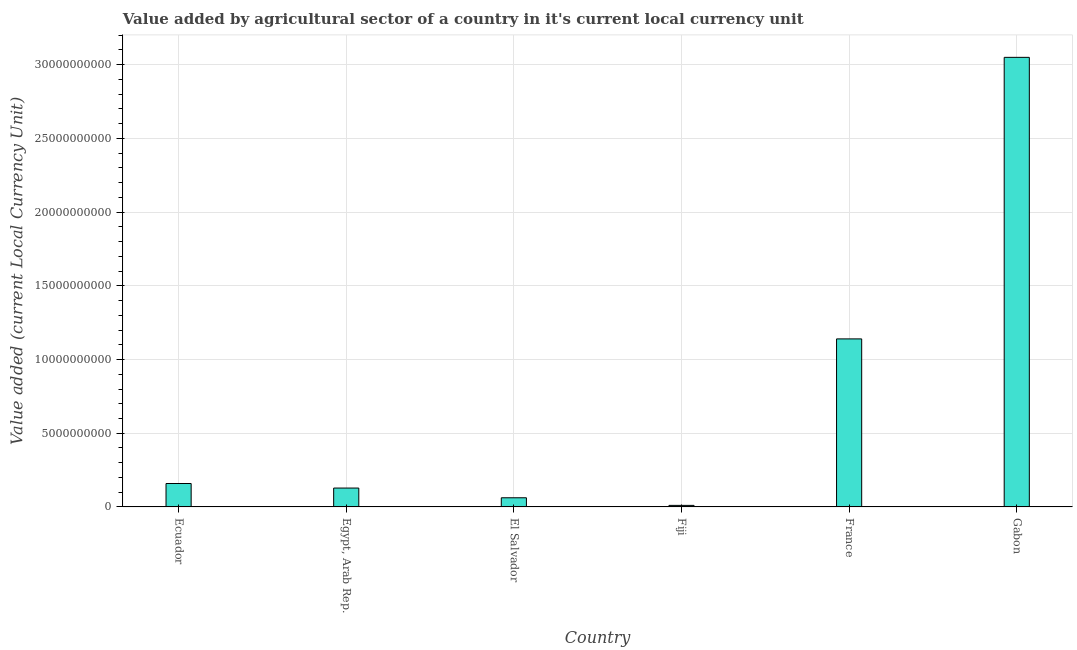Does the graph contain grids?
Give a very brief answer. Yes. What is the title of the graph?
Offer a very short reply. Value added by agricultural sector of a country in it's current local currency unit. What is the label or title of the X-axis?
Make the answer very short. Country. What is the label or title of the Y-axis?
Provide a succinct answer. Value added (current Local Currency Unit). What is the value added by agriculture sector in France?
Provide a short and direct response. 1.14e+1. Across all countries, what is the maximum value added by agriculture sector?
Your answer should be very brief. 3.05e+1. Across all countries, what is the minimum value added by agriculture sector?
Make the answer very short. 1.05e+08. In which country was the value added by agriculture sector maximum?
Provide a succinct answer. Gabon. In which country was the value added by agriculture sector minimum?
Your response must be concise. Fiji. What is the sum of the value added by agriculture sector?
Your answer should be compact. 4.55e+1. What is the difference between the value added by agriculture sector in Egypt, Arab Rep. and Fiji?
Offer a very short reply. 1.18e+09. What is the average value added by agriculture sector per country?
Ensure brevity in your answer.  7.58e+09. What is the median value added by agriculture sector?
Keep it short and to the point. 1.43e+09. In how many countries, is the value added by agriculture sector greater than 17000000000 LCU?
Your response must be concise. 1. What is the ratio of the value added by agriculture sector in Fiji to that in France?
Your answer should be very brief. 0.01. Is the value added by agriculture sector in El Salvador less than that in France?
Give a very brief answer. Yes. What is the difference between the highest and the second highest value added by agriculture sector?
Your response must be concise. 1.91e+1. Is the sum of the value added by agriculture sector in Fiji and France greater than the maximum value added by agriculture sector across all countries?
Offer a terse response. No. What is the difference between the highest and the lowest value added by agriculture sector?
Give a very brief answer. 3.04e+1. In how many countries, is the value added by agriculture sector greater than the average value added by agriculture sector taken over all countries?
Your answer should be very brief. 2. How many bars are there?
Your answer should be very brief. 6. Are all the bars in the graph horizontal?
Offer a very short reply. No. How many countries are there in the graph?
Provide a succinct answer. 6. What is the difference between two consecutive major ticks on the Y-axis?
Give a very brief answer. 5.00e+09. Are the values on the major ticks of Y-axis written in scientific E-notation?
Give a very brief answer. No. What is the Value added (current Local Currency Unit) of Ecuador?
Provide a succinct answer. 1.59e+09. What is the Value added (current Local Currency Unit) of Egypt, Arab Rep.?
Your answer should be very brief. 1.28e+09. What is the Value added (current Local Currency Unit) of El Salvador?
Offer a terse response. 6.21e+08. What is the Value added (current Local Currency Unit) of Fiji?
Provide a short and direct response. 1.05e+08. What is the Value added (current Local Currency Unit) in France?
Provide a succinct answer. 1.14e+1. What is the Value added (current Local Currency Unit) of Gabon?
Offer a very short reply. 3.05e+1. What is the difference between the Value added (current Local Currency Unit) in Ecuador and Egypt, Arab Rep.?
Give a very brief answer. 3.09e+08. What is the difference between the Value added (current Local Currency Unit) in Ecuador and El Salvador?
Your answer should be very brief. 9.68e+08. What is the difference between the Value added (current Local Currency Unit) in Ecuador and Fiji?
Ensure brevity in your answer.  1.48e+09. What is the difference between the Value added (current Local Currency Unit) in Ecuador and France?
Offer a very short reply. -9.81e+09. What is the difference between the Value added (current Local Currency Unit) in Ecuador and Gabon?
Ensure brevity in your answer.  -2.89e+1. What is the difference between the Value added (current Local Currency Unit) in Egypt, Arab Rep. and El Salvador?
Your answer should be very brief. 6.59e+08. What is the difference between the Value added (current Local Currency Unit) in Egypt, Arab Rep. and Fiji?
Provide a short and direct response. 1.18e+09. What is the difference between the Value added (current Local Currency Unit) in Egypt, Arab Rep. and France?
Your answer should be compact. -1.01e+1. What is the difference between the Value added (current Local Currency Unit) in Egypt, Arab Rep. and Gabon?
Your response must be concise. -2.92e+1. What is the difference between the Value added (current Local Currency Unit) in El Salvador and Fiji?
Keep it short and to the point. 5.16e+08. What is the difference between the Value added (current Local Currency Unit) in El Salvador and France?
Offer a very short reply. -1.08e+1. What is the difference between the Value added (current Local Currency Unit) in El Salvador and Gabon?
Offer a very short reply. -2.99e+1. What is the difference between the Value added (current Local Currency Unit) in Fiji and France?
Your answer should be very brief. -1.13e+1. What is the difference between the Value added (current Local Currency Unit) in Fiji and Gabon?
Give a very brief answer. -3.04e+1. What is the difference between the Value added (current Local Currency Unit) in France and Gabon?
Make the answer very short. -1.91e+1. What is the ratio of the Value added (current Local Currency Unit) in Ecuador to that in Egypt, Arab Rep.?
Make the answer very short. 1.24. What is the ratio of the Value added (current Local Currency Unit) in Ecuador to that in El Salvador?
Give a very brief answer. 2.56. What is the ratio of the Value added (current Local Currency Unit) in Ecuador to that in Fiji?
Your answer should be very brief. 15.14. What is the ratio of the Value added (current Local Currency Unit) in Ecuador to that in France?
Your answer should be compact. 0.14. What is the ratio of the Value added (current Local Currency Unit) in Ecuador to that in Gabon?
Your response must be concise. 0.05. What is the ratio of the Value added (current Local Currency Unit) in Egypt, Arab Rep. to that in El Salvador?
Your answer should be very brief. 2.06. What is the ratio of the Value added (current Local Currency Unit) in Egypt, Arab Rep. to that in Fiji?
Offer a very short reply. 12.19. What is the ratio of the Value added (current Local Currency Unit) in Egypt, Arab Rep. to that in France?
Keep it short and to the point. 0.11. What is the ratio of the Value added (current Local Currency Unit) in Egypt, Arab Rep. to that in Gabon?
Provide a short and direct response. 0.04. What is the ratio of the Value added (current Local Currency Unit) in El Salvador to that in Fiji?
Provide a short and direct response. 5.92. What is the ratio of the Value added (current Local Currency Unit) in El Salvador to that in France?
Give a very brief answer. 0.05. What is the ratio of the Value added (current Local Currency Unit) in Fiji to that in France?
Your response must be concise. 0.01. What is the ratio of the Value added (current Local Currency Unit) in Fiji to that in Gabon?
Give a very brief answer. 0. What is the ratio of the Value added (current Local Currency Unit) in France to that in Gabon?
Your answer should be very brief. 0.37. 